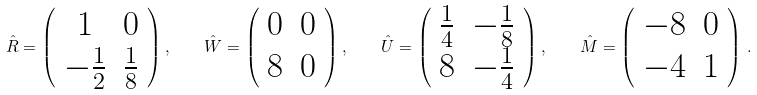<formula> <loc_0><loc_0><loc_500><loc_500>\hat { R } = \left ( \begin{array} { c c } 1 & 0 \\ - \frac { 1 } { 2 } & \frac { 1 } { 8 } \end{array} \right ) , \quad \hat { W } = \left ( \begin{array} { c c } 0 & 0 \\ 8 & 0 \end{array} \right ) , \quad \hat { U } = \left ( \begin{array} { c c } \frac { 1 } { 4 } & - \frac { 1 } { 8 } \\ 8 & - \frac { 1 } { 4 } \end{array} \right ) , \quad \hat { M } = \left ( \begin{array} { c c } - 8 & 0 \\ - 4 & 1 \end{array} \right ) \, .</formula> 